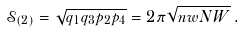<formula> <loc_0><loc_0><loc_500><loc_500>\mathcal { S } _ { ( 2 ) } = \sqrt { q _ { 1 } q _ { 3 } p _ { 2 } p _ { 4 } } = 2 \pi \sqrt { n w N W } \, .</formula> 